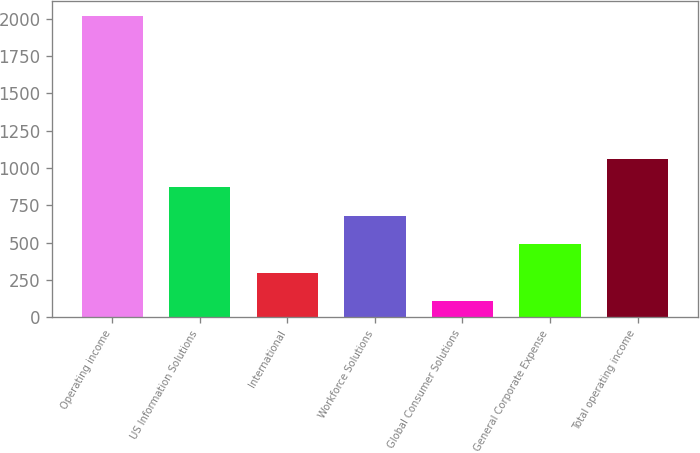<chart> <loc_0><loc_0><loc_500><loc_500><bar_chart><fcel>Operating income<fcel>US Information Solutions<fcel>International<fcel>Workforce Solutions<fcel>Global Consumer Solutions<fcel>General Corporate Expense<fcel>Total operating income<nl><fcel>2017<fcel>870.52<fcel>297.28<fcel>679.44<fcel>106.2<fcel>488.36<fcel>1061.6<nl></chart> 